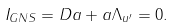<formula> <loc_0><loc_0><loc_500><loc_500>I _ { G N S } = D a + a \Lambda _ { u ^ { \prime } } = 0 .</formula> 